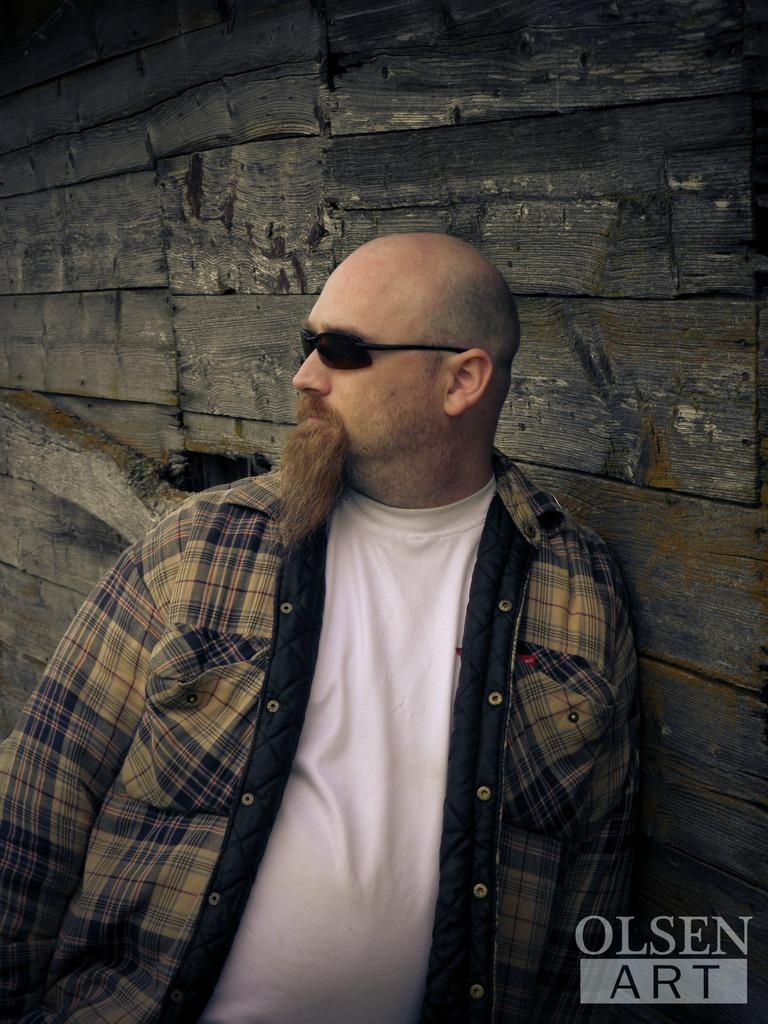Who or what is present in the image? There is a person in the image. What can be seen in the background of the image? There is a wall in the image. Are there any words or symbols visible in the image? Yes, there is text visible on the image. How many lamps are on the trip in the image? There are no lamps or trips present in the image. What type of list can be seen on the wall in the image? There is no list visible on the wall in the image. 